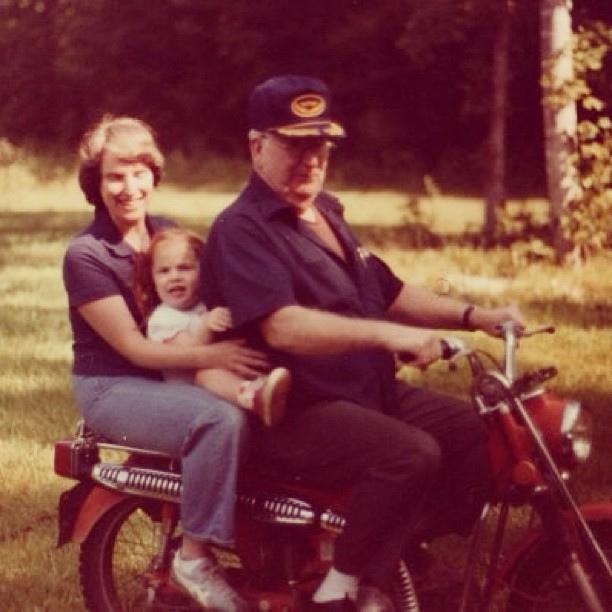How many people are in the photo?
Give a very brief answer. 3. 